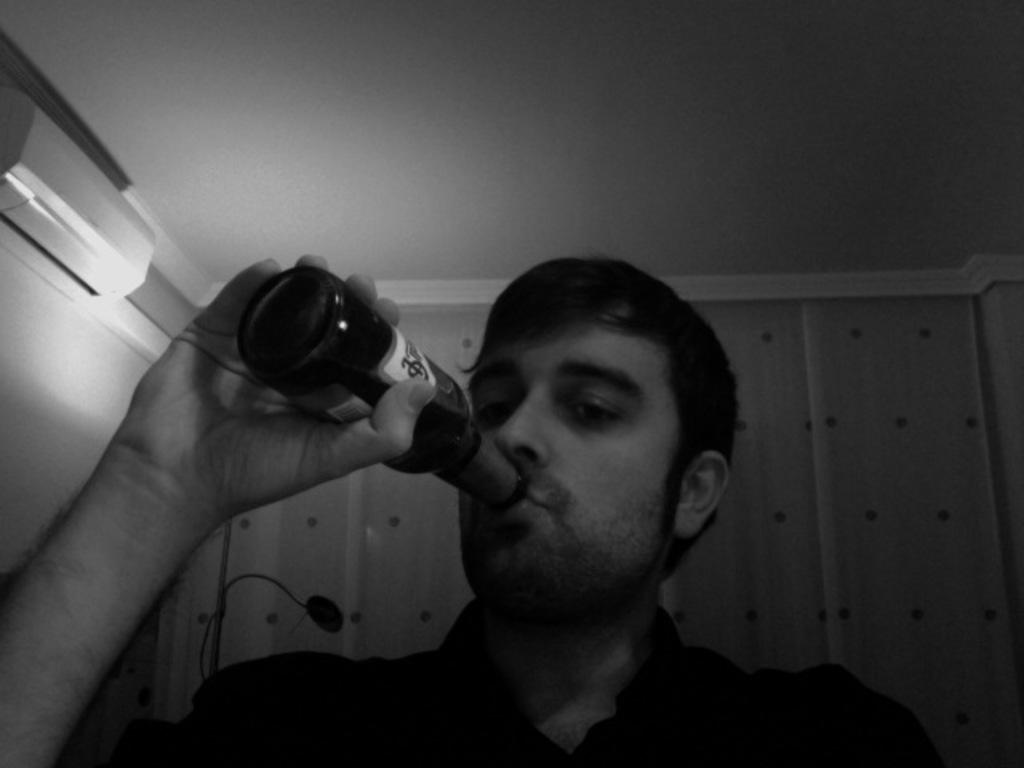Who is present in the image? There is a man in the image. What is the man holding in the image? The man is holding a beverage bottle. What is the man doing with the bottle? The man is drinking from the bottle. What can be seen in the background of the image? There is a wall in the background of the image. What is placed on the wall in the background? There is an air conditioner placed on the wall in the background. What type of balloon is floating near the man in the image? There is no balloon present in the image; the man is holding a beverage bottle and drinking from it. What is the man using to carry his belongings in the image? The man is not carrying any belongings in a sack or any other container in the image. 